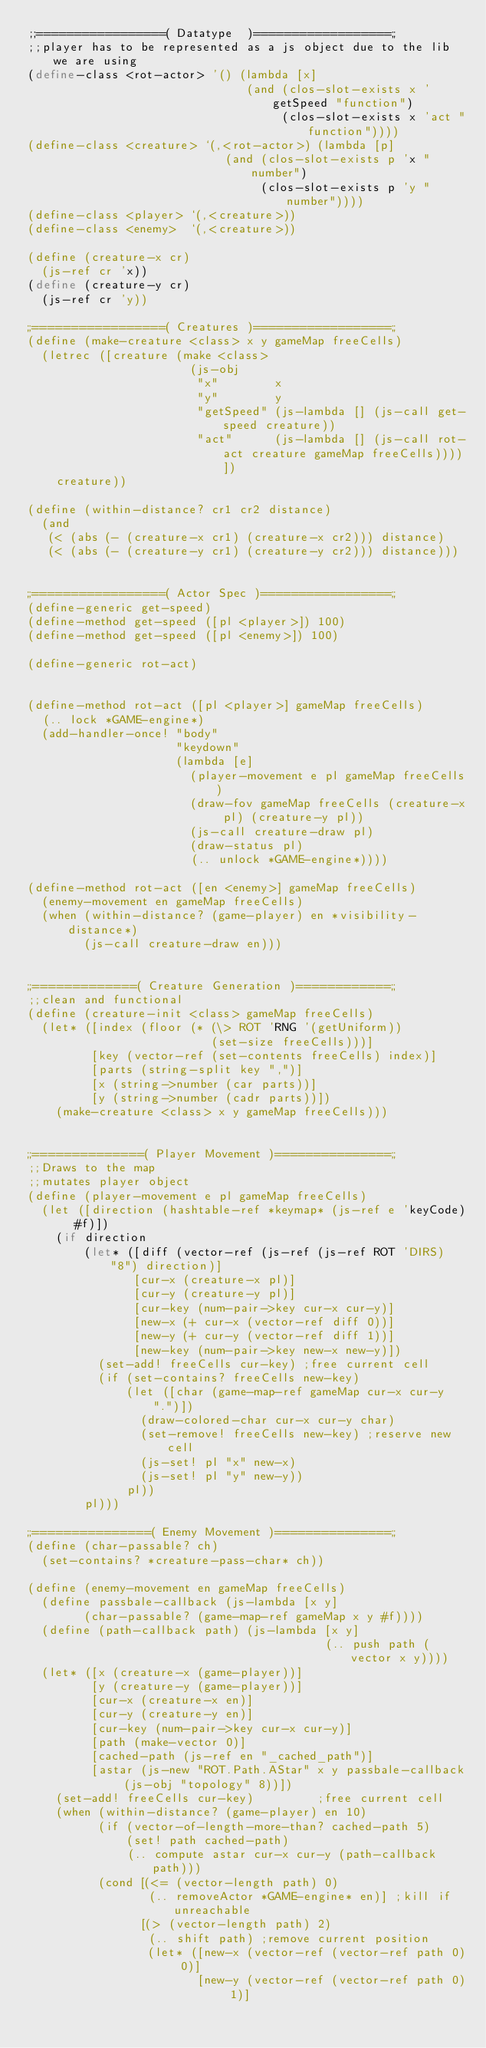<code> <loc_0><loc_0><loc_500><loc_500><_Scheme_>;;=================( Datatype  )==================;;
;;player has to be represented as a js object due to the lib we are using
(define-class <rot-actor> '() (lambda [x]
                               (and (clos-slot-exists x 'getSpeed "function")
                                    (clos-slot-exists x 'act "function"))))
(define-class <creature> `(,<rot-actor>) (lambda [p]
                            (and (clos-slot-exists p 'x "number")
                                 (clos-slot-exists p 'y "number"))))
(define-class <player> `(,<creature>))
(define-class <enemy>  `(,<creature>))

(define (creature-x cr)
  (js-ref cr 'x))
(define (creature-y cr)
  (js-ref cr 'y))

;;=================( Creatures )==================;;
(define (make-creature <class> x y gameMap freeCells)
  (letrec ([creature (make <class>
                       (js-obj
                        "x"        x
                        "y"        y
                        "getSpeed" (js-lambda [] (js-call get-speed creature))
                        "act"      (js-lambda [] (js-call rot-act creature gameMap freeCells))))])
    creature))

(define (within-distance? cr1 cr2 distance)
  (and
   (< (abs (- (creature-x cr1) (creature-x cr2))) distance)
   (< (abs (- (creature-y cr1) (creature-y cr2))) distance)))


;;=================( Actor Spec )=================;;
(define-generic get-speed)
(define-method get-speed ([pl <player>]) 100)
(define-method get-speed ([pl <enemy>]) 100)

(define-generic rot-act)


(define-method rot-act ([pl <player>] gameMap freeCells)
  (.. lock *GAME-engine*)
  (add-handler-once! "body"
                     "keydown"
                     (lambda [e]
                       (player-movement e pl gameMap freeCells)
                       (draw-fov gameMap freeCells (creature-x pl) (creature-y pl))
                       (js-call creature-draw pl)
                       (draw-status pl)
                       (.. unlock *GAME-engine*))))

(define-method rot-act ([en <enemy>] gameMap freeCells)
  (enemy-movement en gameMap freeCells)
  (when (within-distance? (game-player) en *visibility-distance*)
        (js-call creature-draw en)))


;;=============( Creature Generation )============;;
;;clean and functional
(define (creature-init <class> gameMap freeCells)
  (let* ([index (floor (* (\> ROT 'RNG '(getUniform))
                          (set-size freeCells)))]
         [key (vector-ref (set-contents freeCells) index)]
         [parts (string-split key ",")]
         [x (string->number (car parts))]
         [y (string->number (cadr parts))])
    (make-creature <class> x y gameMap freeCells)))


;;==============( Player Movement )===============;;
;;Draws to the map
;;mutates player object
(define (player-movement e pl gameMap freeCells)
  (let ([direction (hashtable-ref *keymap* (js-ref e 'keyCode) #f)])
    (if direction
        (let* ([diff (vector-ref (js-ref (js-ref ROT 'DIRS) "8") direction)]
               [cur-x (creature-x pl)]
               [cur-y (creature-y pl)]
               [cur-key (num-pair->key cur-x cur-y)]
               [new-x (+ cur-x (vector-ref diff 0))]
               [new-y (+ cur-y (vector-ref diff 1))]
               [new-key (num-pair->key new-x new-y)])
          (set-add! freeCells cur-key) ;free current cell
          (if (set-contains? freeCells new-key)
              (let ([char (game-map-ref gameMap cur-x cur-y ".")])
                (draw-colored-char cur-x cur-y char)
                (set-remove! freeCells new-key) ;reserve new cell
                (js-set! pl "x" new-x)
                (js-set! pl "y" new-y))
              pl))
        pl)))

;;===============( Enemy Movement )===============;;
(define (char-passable? ch)
  (set-contains? *creature-pass-char* ch))

(define (enemy-movement en gameMap freeCells)
  (define passbale-callback (js-lambda [x y]
        (char-passable? (game-map-ref gameMap x y #f))))
  (define (path-callback path) (js-lambda [x y]
                                          (.. push path (vector x y))))
  (let* ([x (creature-x (game-player))]
         [y (creature-y (game-player))]
         [cur-x (creature-x en)]
         [cur-y (creature-y en)]
         [cur-key (num-pair->key cur-x cur-y)]
         [path (make-vector 0)]
         [cached-path (js-ref en "_cached_path")]
         [astar (js-new "ROT.Path.AStar" x y passbale-callback (js-obj "topology" 8))])
    (set-add! freeCells cur-key)         ;free current cell
    (when (within-distance? (game-player) en 10)
          (if (vector-of-length-more-than? cached-path 5)
              (set! path cached-path)
              (.. compute astar cur-x cur-y (path-callback path)))
          (cond [(<= (vector-length path) 0)
                 (.. removeActor *GAME-engine* en)] ;kill if unreachable
                [(> (vector-length path) 2)
                 (.. shift path) ;remove current position
                 (let* ([new-x (vector-ref (vector-ref path 0) 0)]
                        [new-y (vector-ref (vector-ref path 0) 1)]</code> 